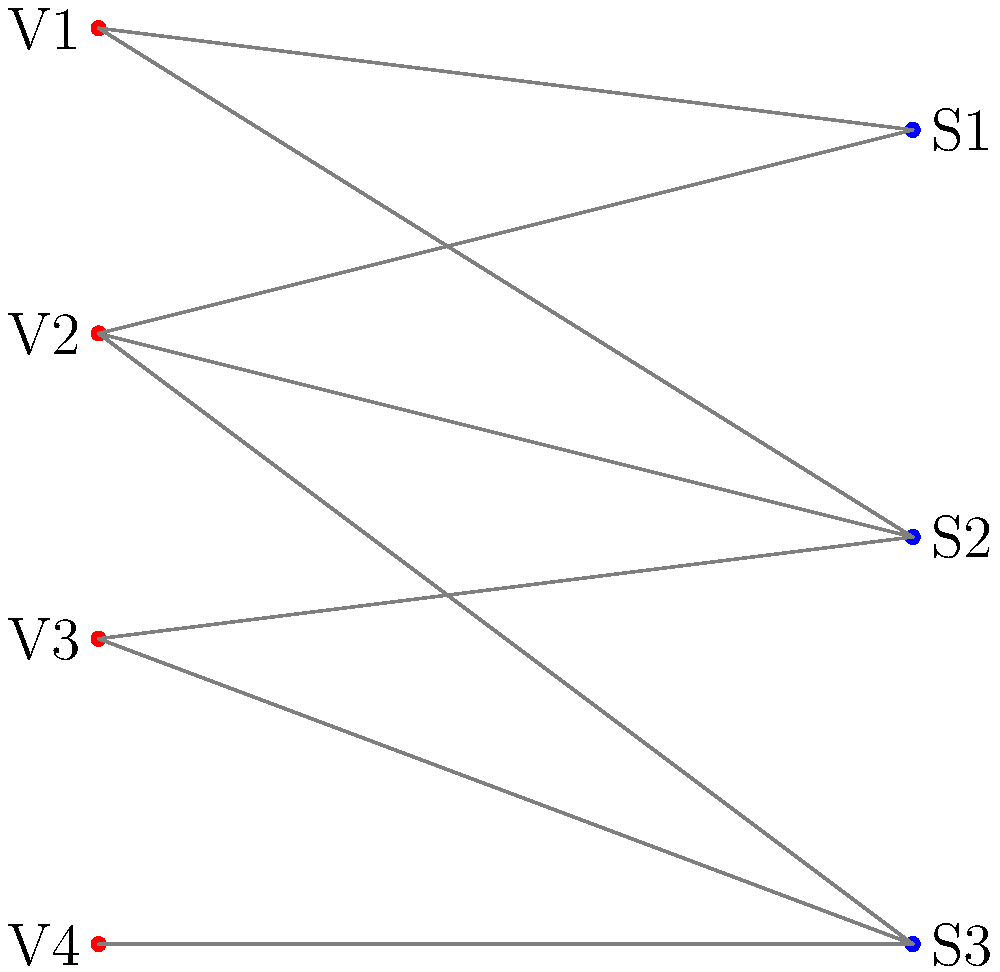As a volunteer coordinator at a local cancer support organization, you need to assign volunteers to different shifts. The bipartite graph above represents the availability of volunteers (V1-V4) for specific shifts (S1-S3). What is the maximum number of shifts that can be filled, and which matching achieves this? To solve this problem, we need to find the maximum matching in the bipartite graph. We can use the following steps:

1. Identify the vertices: 
   - Left set (Volunteers): V1, V2, V3, V4
   - Right set (Shifts): S1, S2, S3

2. List the edges (availabilities):
   - V1 -- S1, V1 -- S2
   - V2 -- S1, V2 -- S2, V2 -- S3
   - V3 -- S2, V3 -- S3
   - V4 -- S3

3. Apply the augmenting path algorithm:
   a) Start with an empty matching
   b) Find an augmenting path: V1 -- S1
      Matching: {(V1, S1)}
   c) Find another augmenting path: V2 -- S2
      Matching: {(V1, S1), (V2, S2)}
   d) Find another augmenting path: V4 -- S3
      Matching: {(V1, S1), (V2, S2), (V4, S3)}

4. No more augmenting paths can be found, so this is the maximum matching.

The maximum number of shifts that can be filled is 3, which is the size of the maximum matching.

The matching that achieves this is:
- V1 assigned to S1
- V2 assigned to S2
- V4 assigned to S3

This matching ensures that all three shifts are covered while respecting the availability constraints of the volunteers.
Answer: 3 shifts; V1-S1, V2-S2, V4-S3 